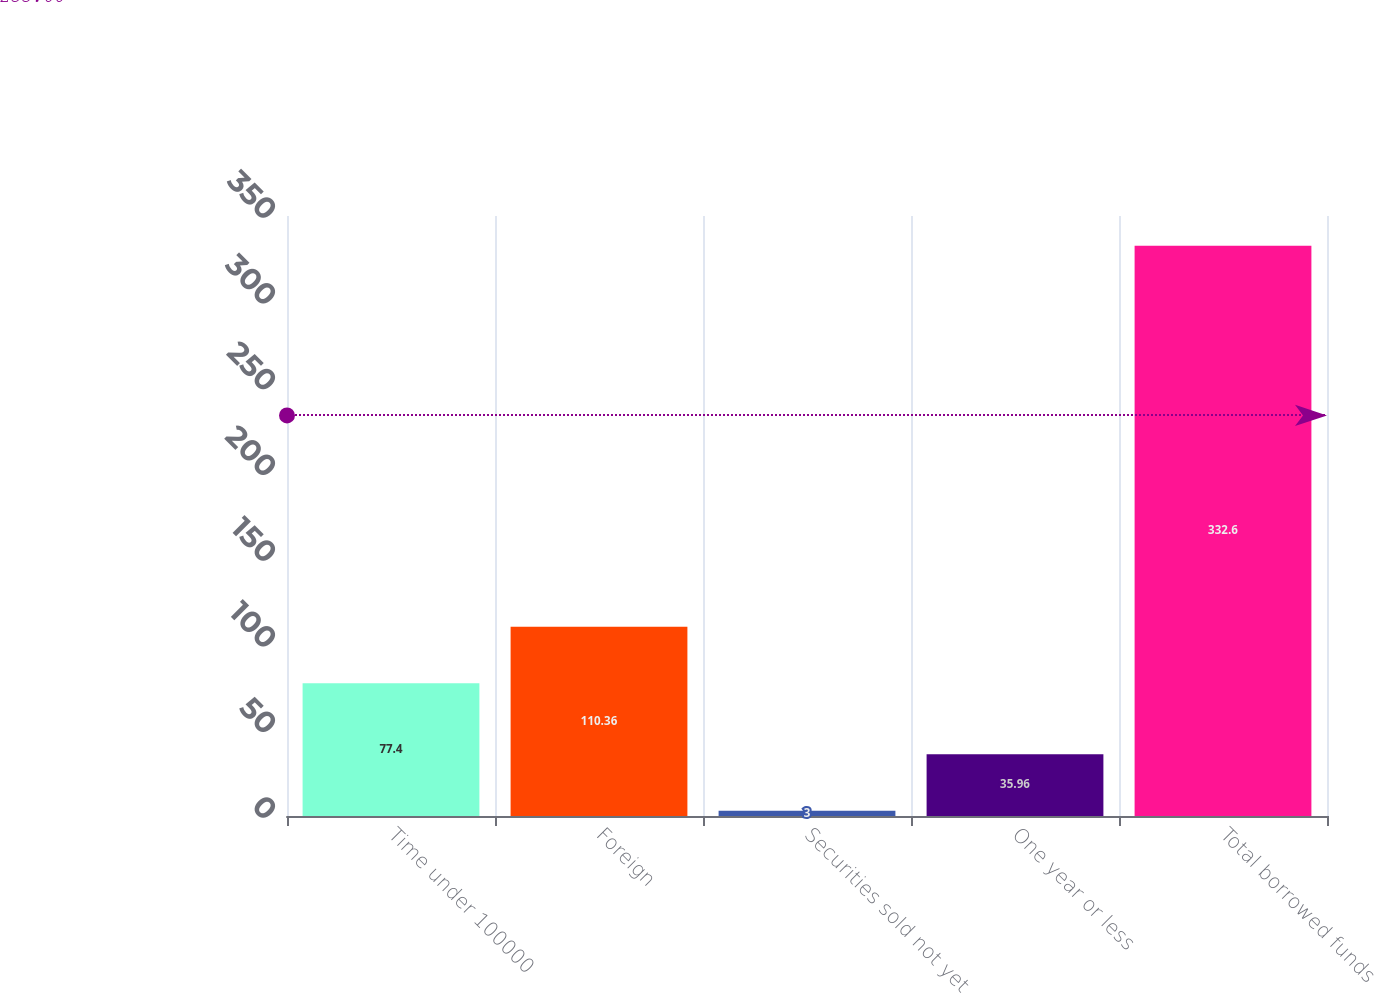Convert chart. <chart><loc_0><loc_0><loc_500><loc_500><bar_chart><fcel>Time under 100000<fcel>Foreign<fcel>Securities sold not yet<fcel>One year or less<fcel>Total borrowed funds<nl><fcel>77.4<fcel>110.36<fcel>3<fcel>35.96<fcel>332.6<nl></chart> 